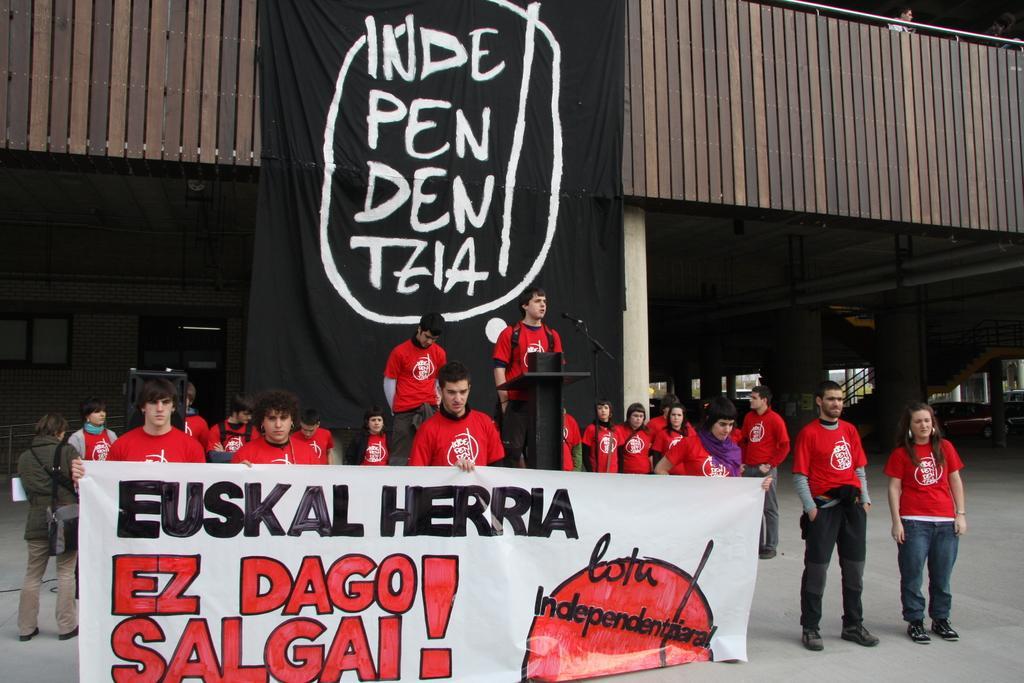Please provide a concise description of this image. At the top of the image we can see wooden grill and an advertisement. At the bottom of the image we can see stair case, pillars, walls and some persons standing on the floor and two men standing on the dais. We can see an advertisement being held by the men. 